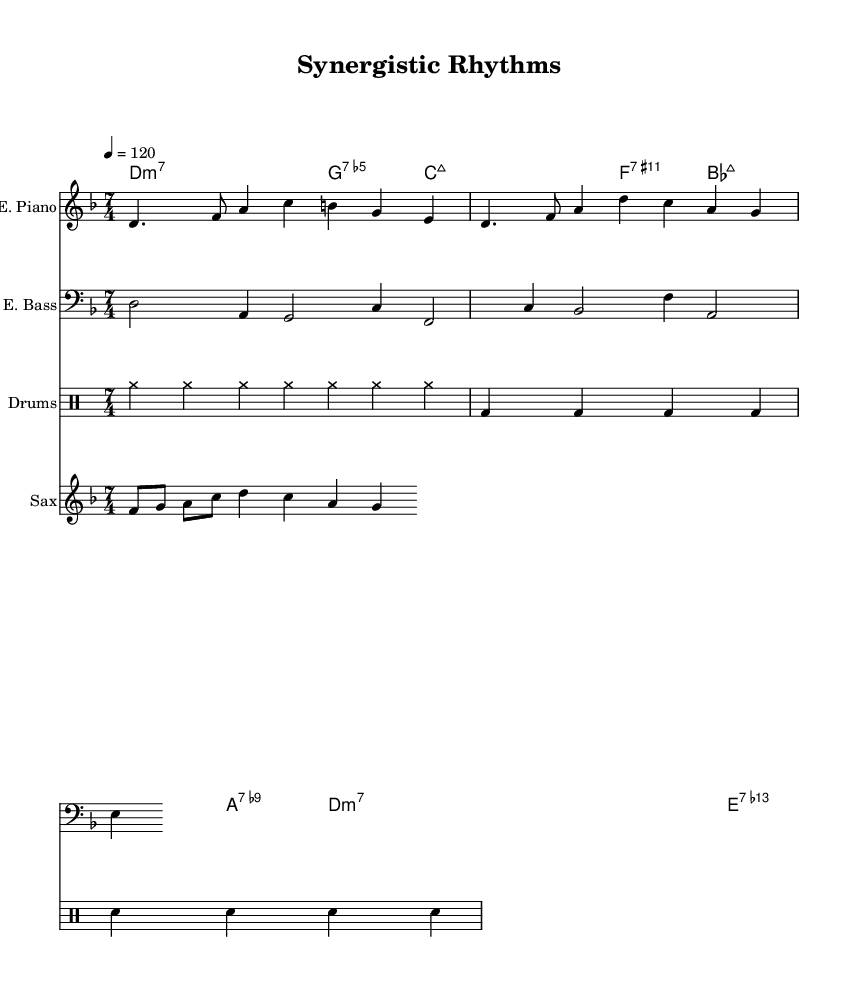What is the key signature of this music? The key signature is D minor, which contains one flat (B-flat). It is indicated at the beginning of the staff lines.
Answer: D minor What is the time signature of this music? The time signature is 7/4, as shown at the beginning of the staff lines. This indicates there are seven beats in each measure, and the quarter note receives one beat.
Answer: 7/4 What is the tempo marking of this piece? The tempo marking is 120 beats per minute (bpm), indicated by the "4 = 120" marking at the beginning. This means the quarter note is played at this tempo.
Answer: 120 How many measures are indicated in the section? The sheet music shows 4 complete measures in each part, based on the physical layout of notes and rests.
Answer: 4 Which instruments are featured in this score? The score features electric piano, electric bass, drums, and saxophone, as identified by specific instrument names above each staff.
Answer: Electric Piano, Electric Bass, Drums, Saxophone What is the first chord in the chord progression? The first chord in the chord progression is D minor 7 (D:m7), as shown at the start of the chord names section. This indicates the harmonization for the first measure.
Answer: D:m7 How does the rhythm in the electric piano part compare to the drums? The rhythm in the electric piano part has a more complex pattern using dotted and eighth notes, while the drums maintain a steady pulse primarily through quarter notes and cymbal hits. This contrast emphasizes innovation in rhythmic structure typical in contemporary jazz fusion.
Answer: Complex vs. Steady 